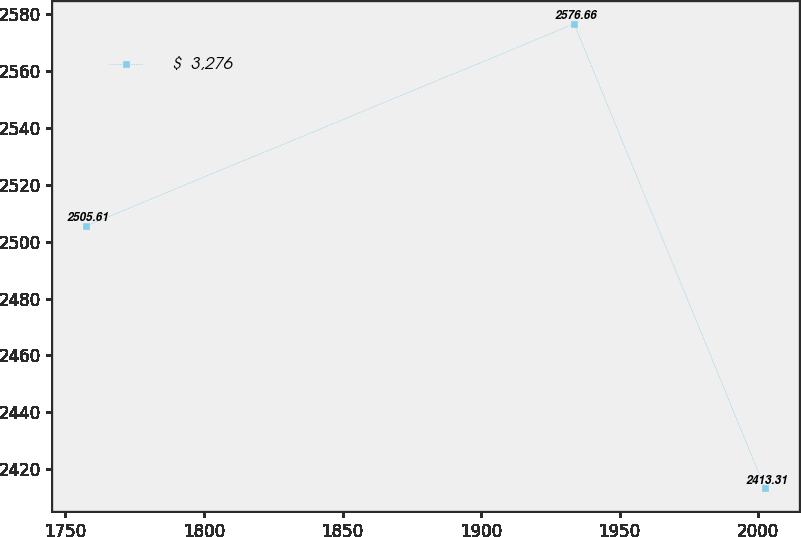<chart> <loc_0><loc_0><loc_500><loc_500><line_chart><ecel><fcel>$  3,276<nl><fcel>1757.54<fcel>2505.61<nl><fcel>1933.6<fcel>2576.66<nl><fcel>2002.5<fcel>2413.31<nl></chart> 